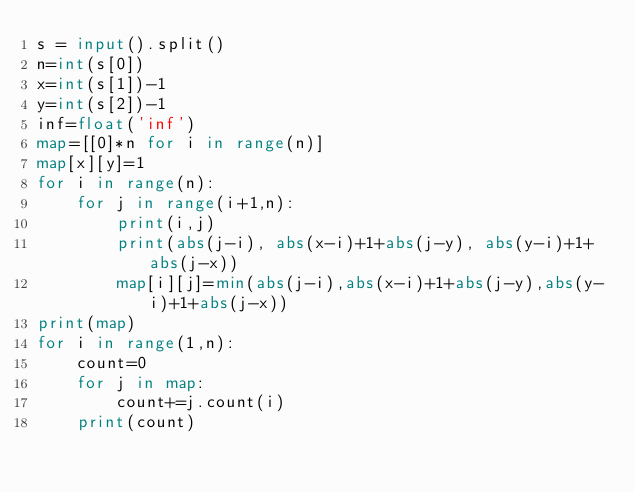Convert code to text. <code><loc_0><loc_0><loc_500><loc_500><_Python_>s = input().split()
n=int(s[0])
x=int(s[1])-1
y=int(s[2])-1
inf=float('inf')
map=[[0]*n for i in range(n)]
map[x][y]=1
for i in range(n):
    for j in range(i+1,n):
        print(i,j)
        print(abs(j-i), abs(x-i)+1+abs(j-y), abs(y-i)+1+abs(j-x))
        map[i][j]=min(abs(j-i),abs(x-i)+1+abs(j-y),abs(y-i)+1+abs(j-x))
print(map)
for i in range(1,n):
    count=0
    for j in map:
        count+=j.count(i)
    print(count)
</code> 